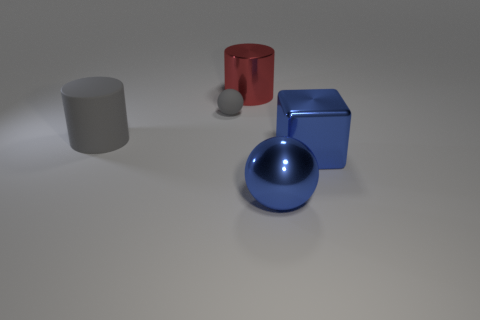Add 5 small matte balls. How many objects exist? 10 Subtract 1 cylinders. How many cylinders are left? 1 Subtract all yellow cylinders. Subtract all red cubes. How many cylinders are left? 2 Subtract all yellow cubes. How many red cylinders are left? 1 Subtract all gray rubber balls. Subtract all matte balls. How many objects are left? 3 Add 1 tiny gray spheres. How many tiny gray spheres are left? 2 Add 5 small gray matte objects. How many small gray matte objects exist? 6 Subtract all red cylinders. How many cylinders are left? 1 Subtract 1 blue balls. How many objects are left? 4 Subtract all cubes. How many objects are left? 4 